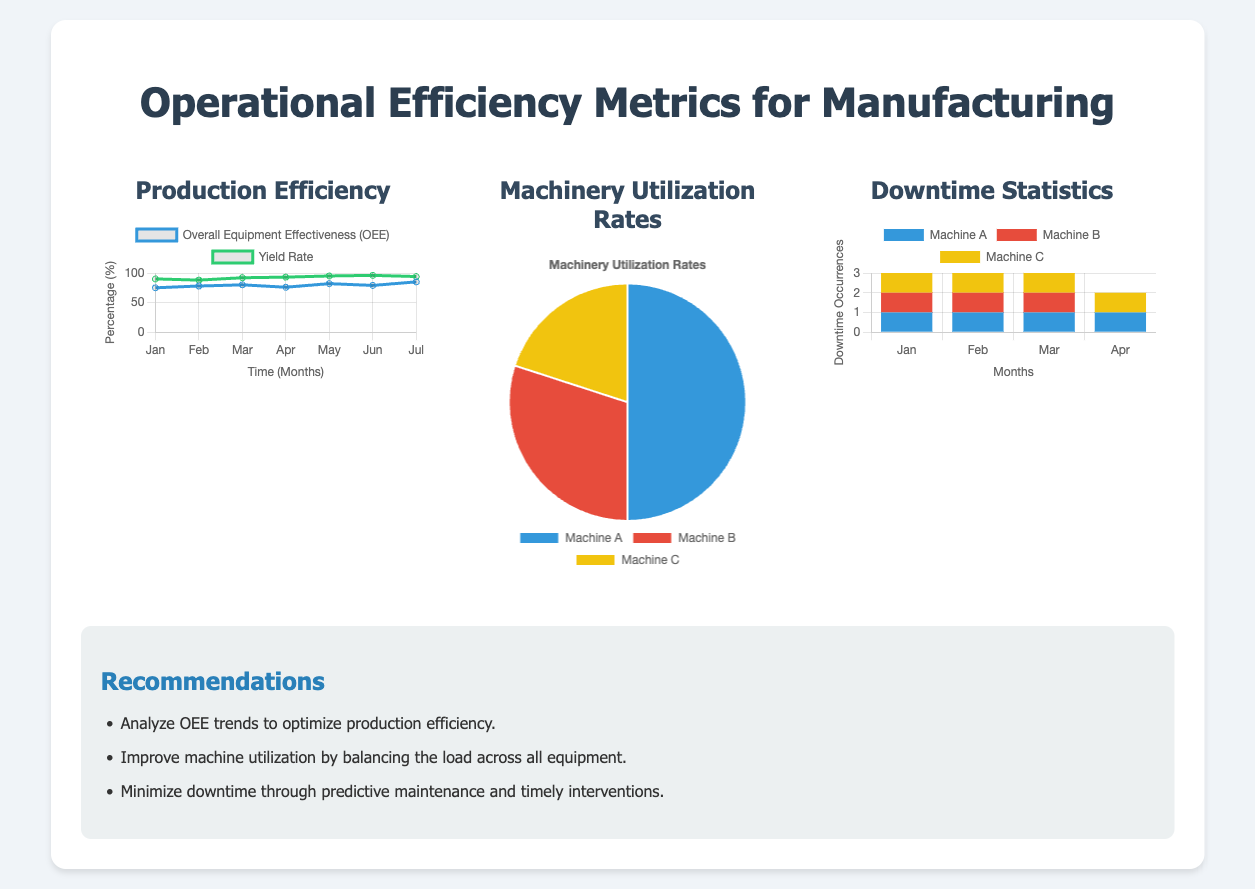What is the highest OEE value shown? The highest value for Overall Equipment Effectiveness (OEE) on the production efficiency chart is 85.
Answer: 85 What month shows the lowest yield rate? The yield rate chart indicates that February shows the lowest yield rate at 88%.
Answer: 88% Which machine has the highest utilization rate? In the machinery utilization pie chart, Machine A has the highest utilization rate at 50%.
Answer: Machine A How many months are shown in the downtime statistics? The downtime statistics chart covers four months, specifically January to April.
Answer: Four What is the total number of downtime occurrences for Machine B in April? The downtime statistics show that Machine B had 0 occurrences in April.
Answer: 0 What are the two main products tracked in the production efficiency metrics? The key metrics tracked are Overall Equipment Effectiveness (OEE) and Yield Rate.
Answer: Overall Equipment Effectiveness (OEE) and Yield Rate What is the primary recommendation for improving machinery utilization? The recommendation for improving machinery utilization is to balance the load across all equipment.
Answer: Balance the load across all equipment What is the background color for the data representing Machine C in the downtime statistics? The background color representing Machine C in the downtime statistics is yellow.
Answer: Yellow What type of chart is used to display machinery utilization rates? The machinery utilization rates are displayed using a pie chart.
Answer: Pie chart 